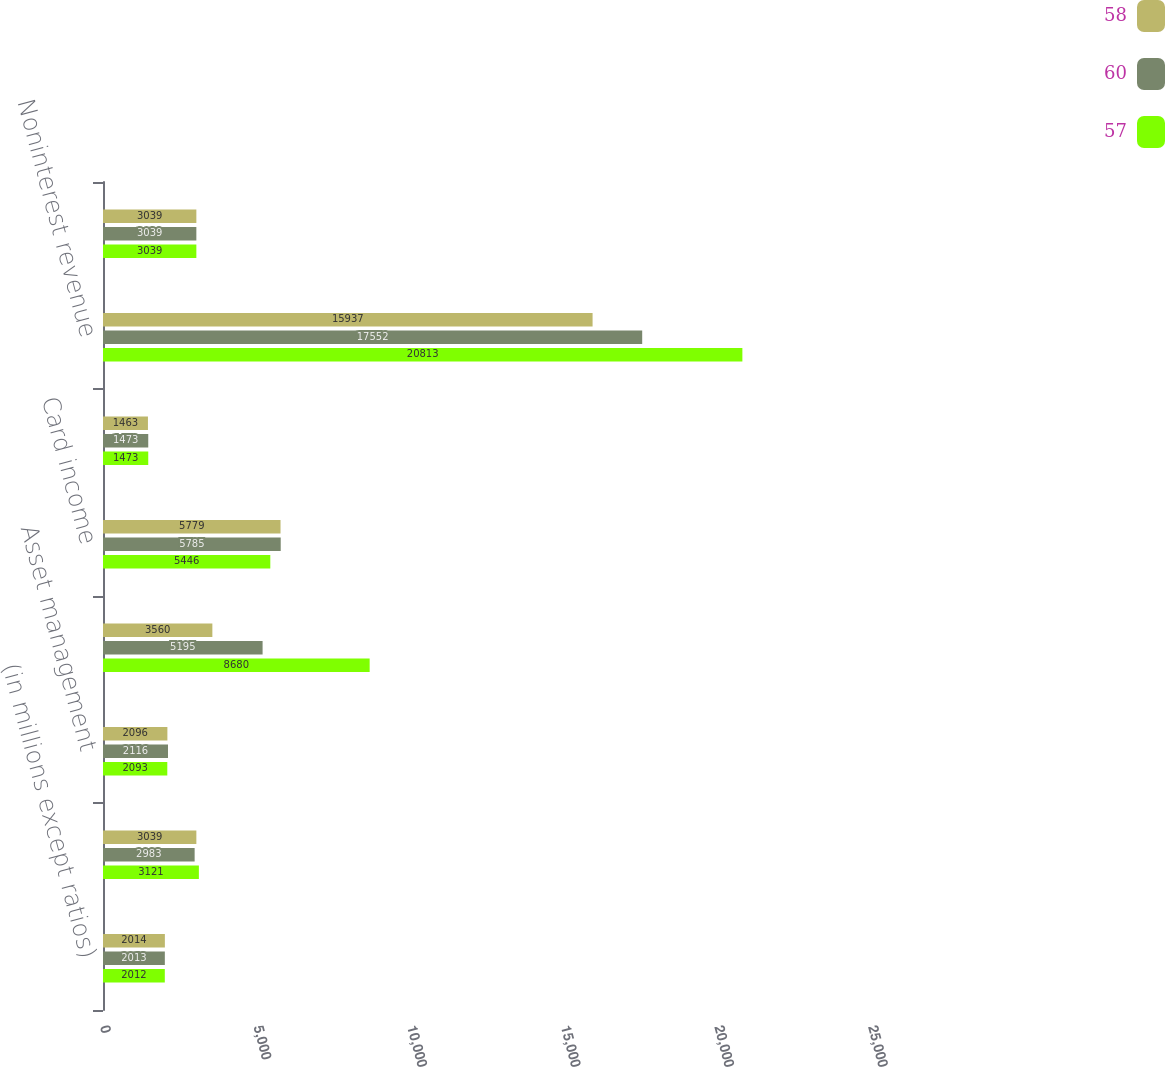Convert chart. <chart><loc_0><loc_0><loc_500><loc_500><stacked_bar_chart><ecel><fcel>(in millions except ratios)<fcel>Lending- and deposit-related<fcel>Asset management<fcel>Mortgage fees and related<fcel>Card income<fcel>All other income<fcel>Noninterest revenue<fcel>Net interest income<nl><fcel>58<fcel>2014<fcel>3039<fcel>2096<fcel>3560<fcel>5779<fcel>1463<fcel>15937<fcel>3039<nl><fcel>60<fcel>2013<fcel>2983<fcel>2116<fcel>5195<fcel>5785<fcel>1473<fcel>17552<fcel>3039<nl><fcel>57<fcel>2012<fcel>3121<fcel>2093<fcel>8680<fcel>5446<fcel>1473<fcel>20813<fcel>3039<nl></chart> 